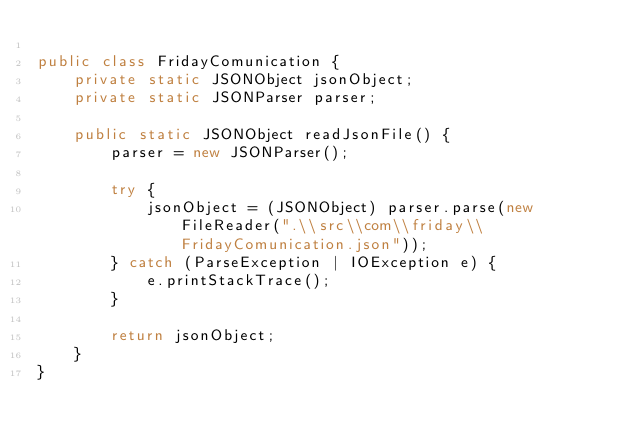<code> <loc_0><loc_0><loc_500><loc_500><_Java_>
public class FridayComunication {
    private static JSONObject jsonObject;
    private static JSONParser parser;

    public static JSONObject readJsonFile() {
        parser = new JSONParser();

        try {
            jsonObject = (JSONObject) parser.parse(new FileReader(".\\src\\com\\friday\\FridayComunication.json"));
        } catch (ParseException | IOException e) {
            e.printStackTrace();
        }

        return jsonObject;
    }
}</code> 